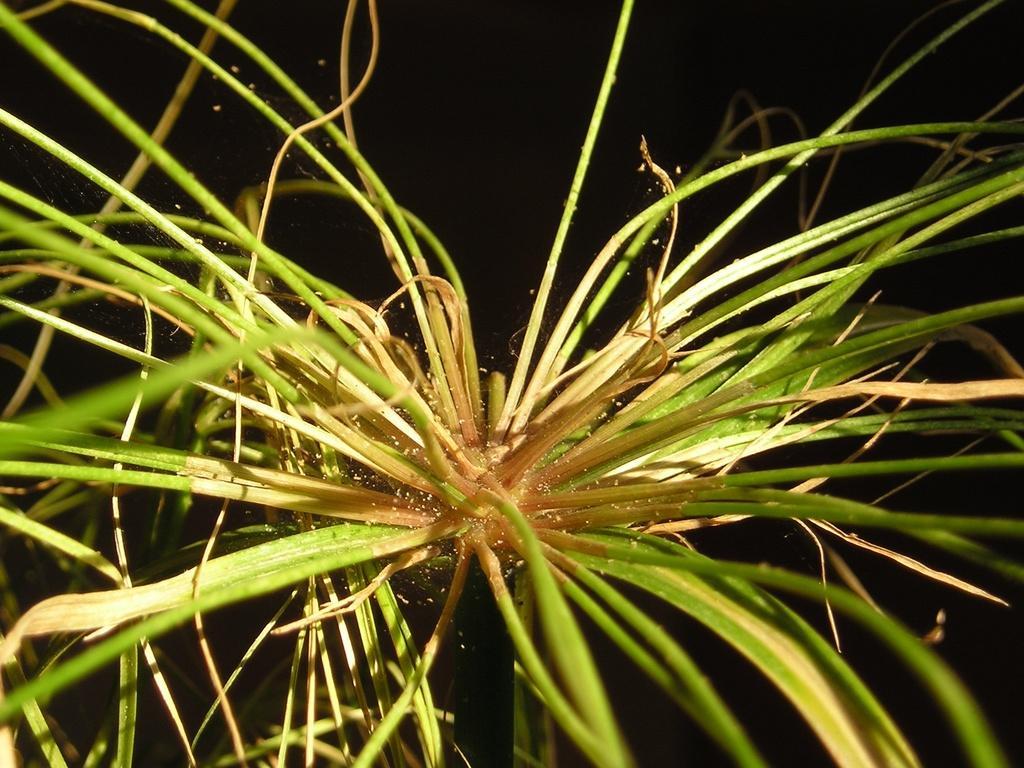How would you summarize this image in a sentence or two? In this image we can see a plant and the background is dark. 